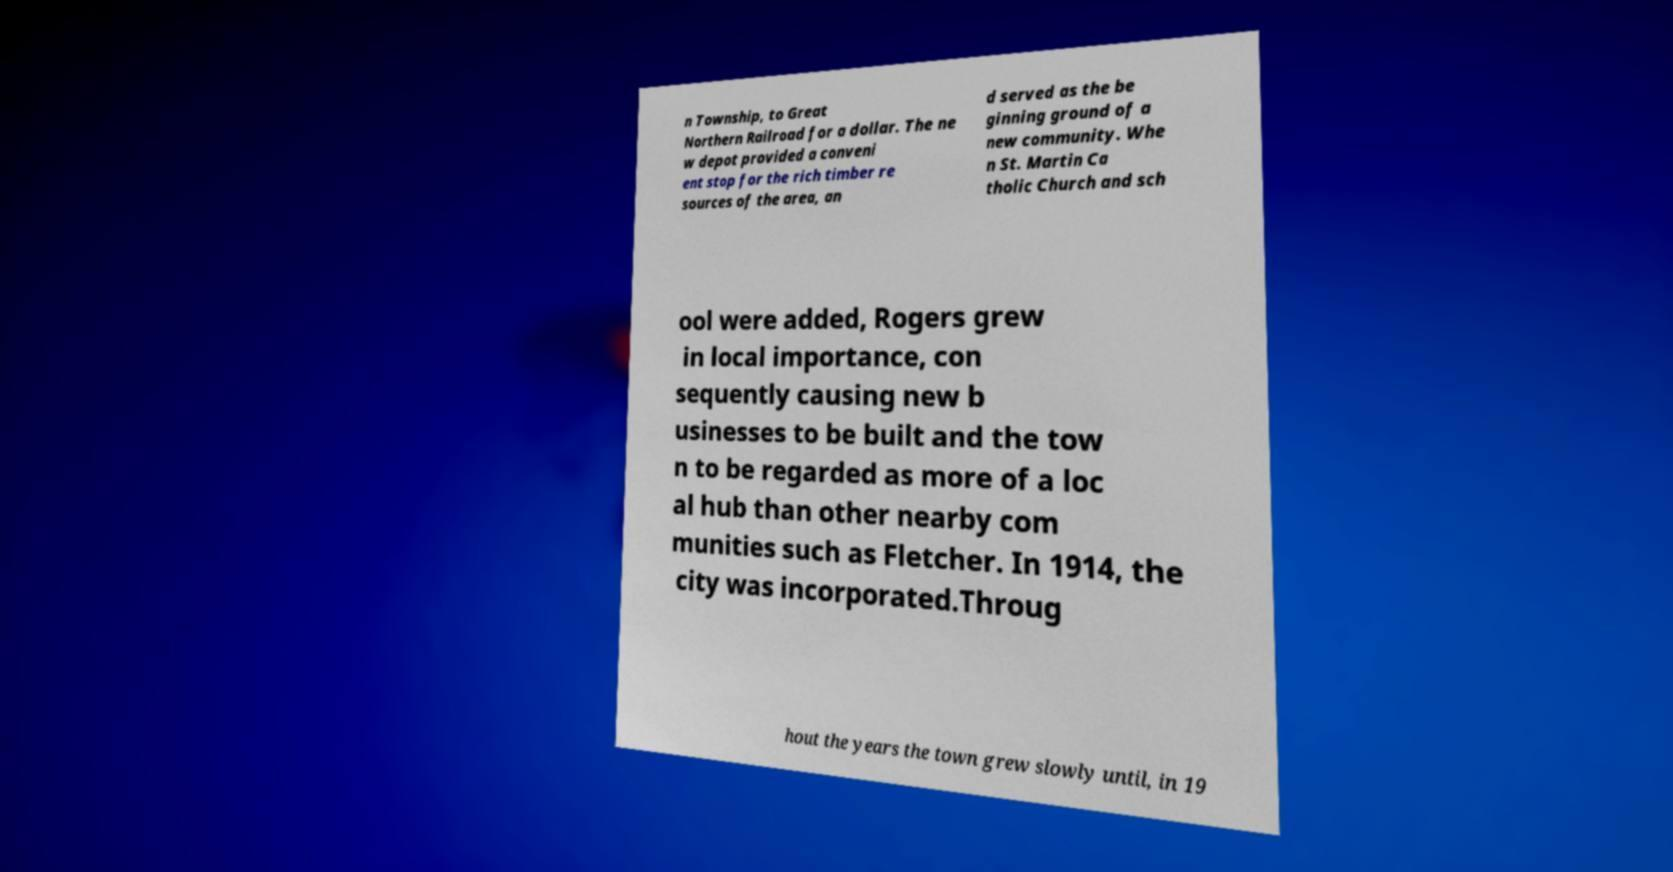I need the written content from this picture converted into text. Can you do that? n Township, to Great Northern Railroad for a dollar. The ne w depot provided a conveni ent stop for the rich timber re sources of the area, an d served as the be ginning ground of a new community. Whe n St. Martin Ca tholic Church and sch ool were added, Rogers grew in local importance, con sequently causing new b usinesses to be built and the tow n to be regarded as more of a loc al hub than other nearby com munities such as Fletcher. In 1914, the city was incorporated.Throug hout the years the town grew slowly until, in 19 